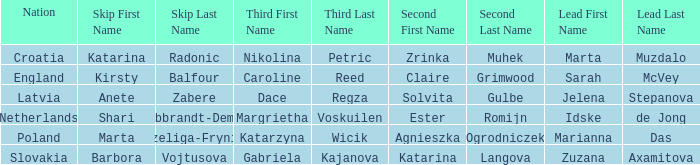Which skip has Zrinka Muhek as Second? Katarina Radonic. 